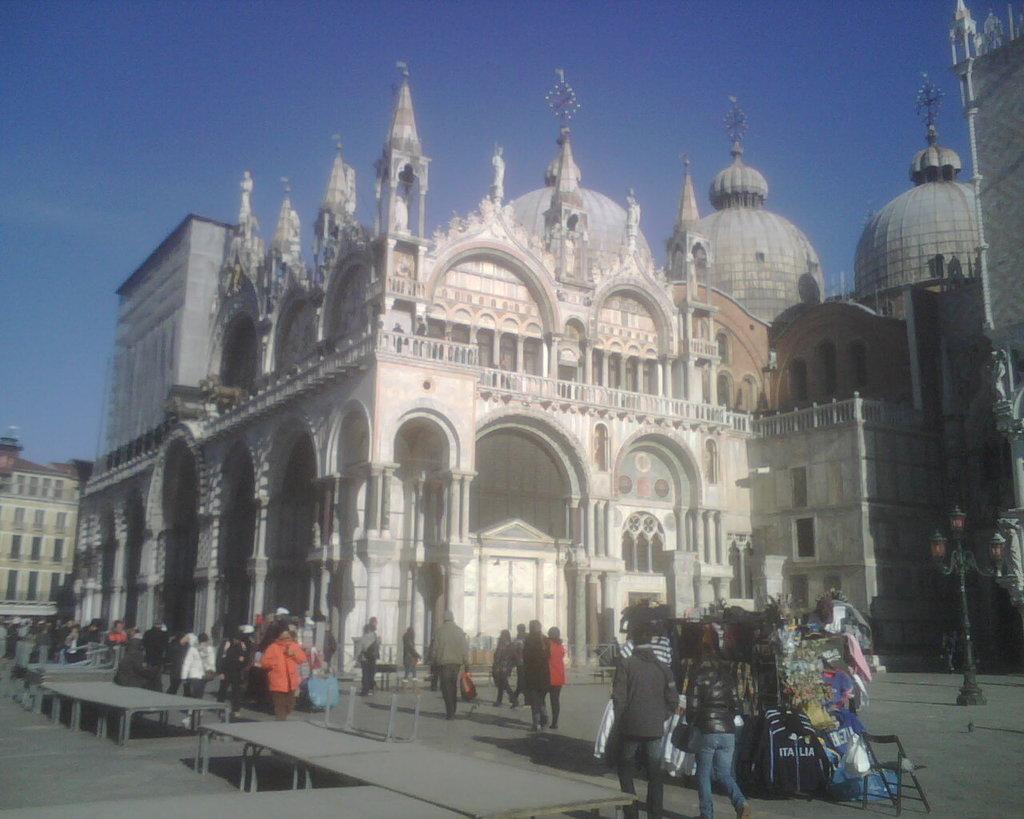How would you summarize this image in a sentence or two? In this picture there are few persons standing and there are few clothes placed on an object in the right corner and there are buildings in the background. 